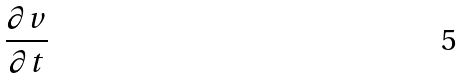Convert formula to latex. <formula><loc_0><loc_0><loc_500><loc_500>\frac { \partial v } { \partial t }</formula> 